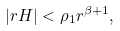Convert formula to latex. <formula><loc_0><loc_0><loc_500><loc_500>| r H | < \rho _ { 1 } r ^ { \beta + 1 } ,</formula> 